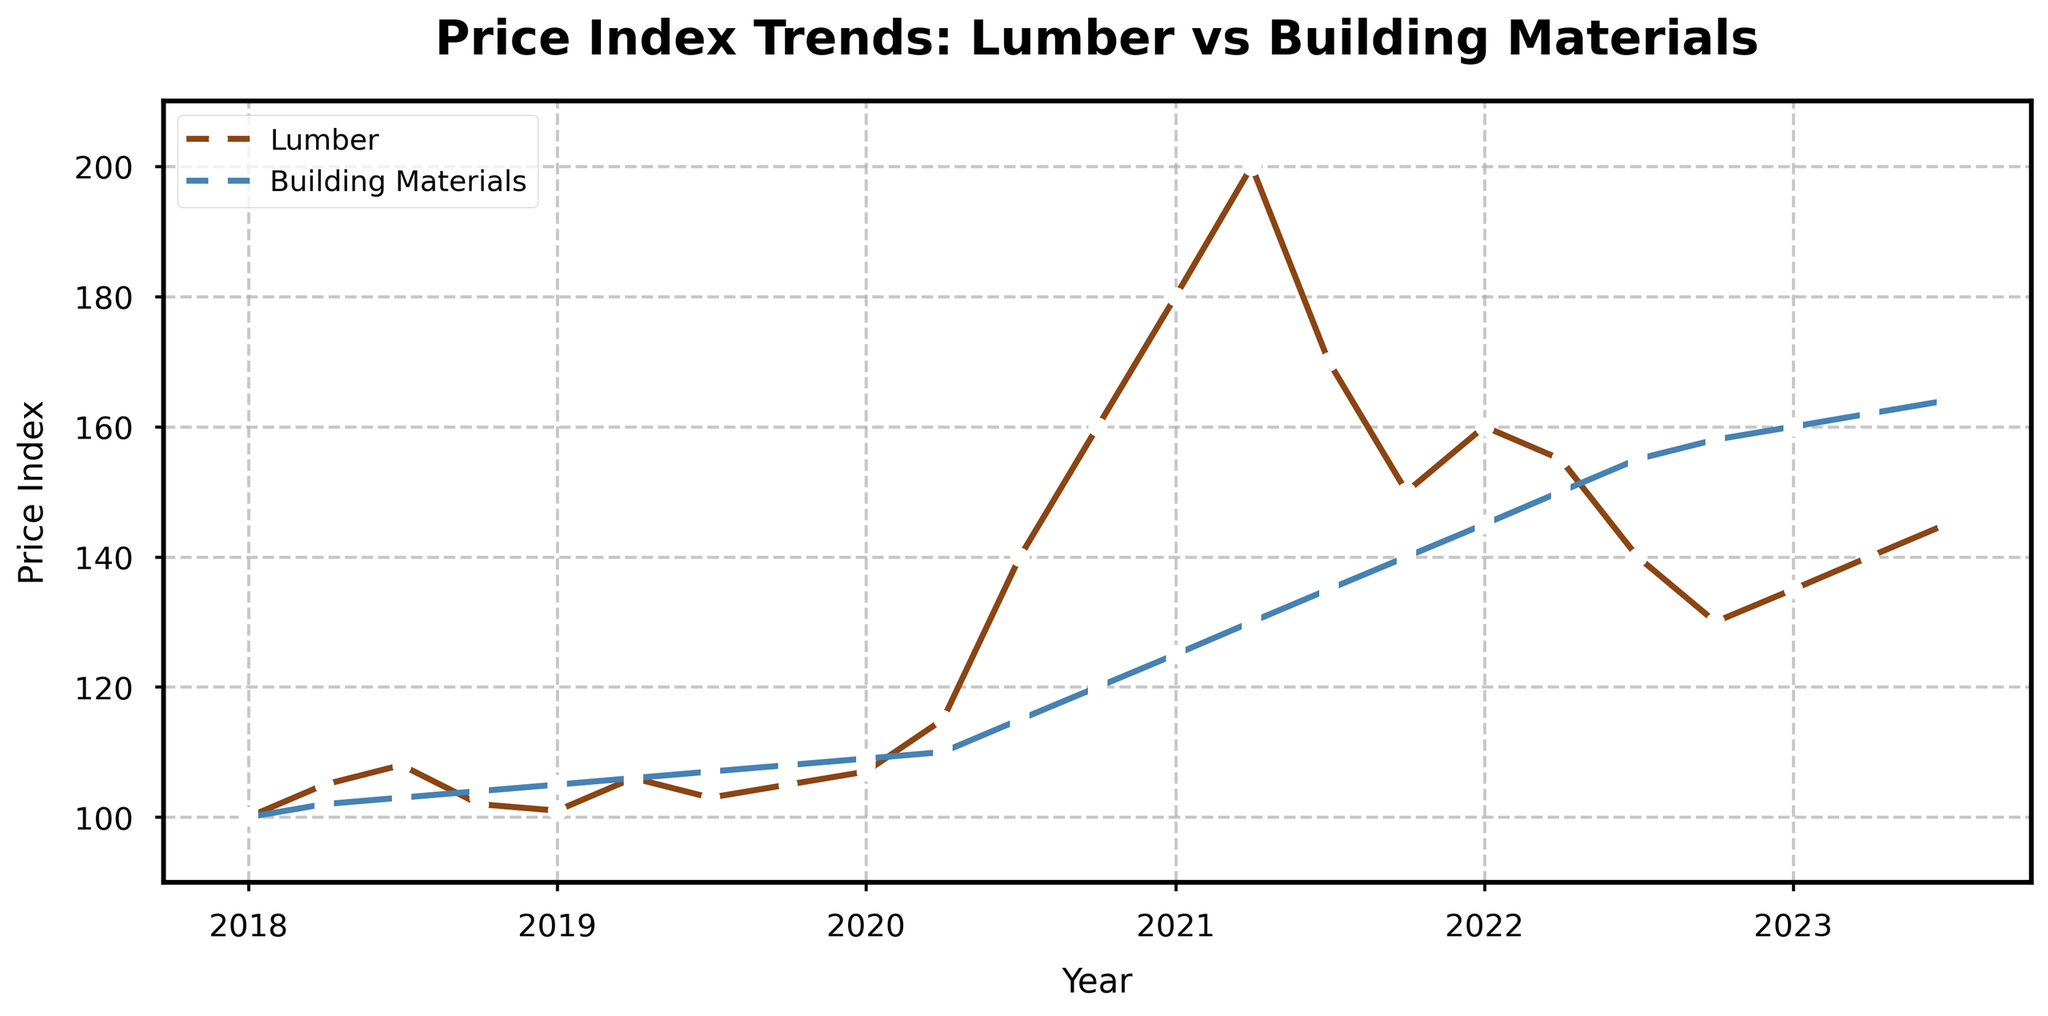Which month shows the highest Lumber Price Index? The highest Lumber Price Index is observed around the peak point of the lumber line. Based on the plot, the peak occurs around April 2021.
Answer: April 2021 During which year did the Building Materials Price Index first exceed 150? The first step is to identify the graph line representing the Building Materials Price Index. Observing the line's rise, the index crosses the 150 mark around early 2022.
Answer: 2022 What is the difference between the Lumber Price Index and the Building Materials Price Index in July 2020? Locate the points for July 2020 on both lines. The Lumber Price Index is approximately 140, and the Building Materials Price Index is about 115. The difference is 140 - 115.
Answer: 25 By how much did the Lumber Price Index increase from January 2020 to April 2021? Find January 2020 on the Lumber Price Index line, which is approximately 107. Then find April 2021, which is around 200. The increase is 200 - 107.
Answer: 93 In which year was the Lumber Price Index lower in the fourth quarter compared to the first quarter of that same year? Compare first and fourth-quarter indexes for each year. In 2018, the index dropped from around 105 in April to 102 in October.
Answer: 2018 What trend can you observe in the Building Materials Price Index between October 2021 and July 2022? Observe the Building Materials Price Index line from October 2021 to July 2022. It shows a consistent increase from about 140 to 155.
Answer: Increasing What is the average Building Materials Price Index for the year 2019? Find the indexes for 2019 (105, 106, 107, 108), sum them up (105+106+107+108) to get 426. Divide by the number of data points (4).
Answer: 106.5 Which index had a more significant increase from October 2020 to January 2021: Lumber Price or Building Materials Price? Observe the change in both indexes from October 2020 to January 2021. Lumber Price Index increased from 160 to 180 (an increase of 20), while Building Materials Price increased from 120 to 125 (an increase of 5).
Answer: Lumber Price During which quarter of 2023 did the Lumber Price Index reach its highest level? Check the 2023 data points for the Lumber Price Index. The highest level in 2023 occurs in the third quarter (July) at 145.
Answer: Third quarter How many times does the Lumber Price Index peak above 150? Count the occurrences where the Lumber Price Index surpasses the 150 mark. The peaks happen around April 2021 and continue until early 2022, resulting in 3 peaks (April 2021, July 2021, January 2022).
Answer: 3 